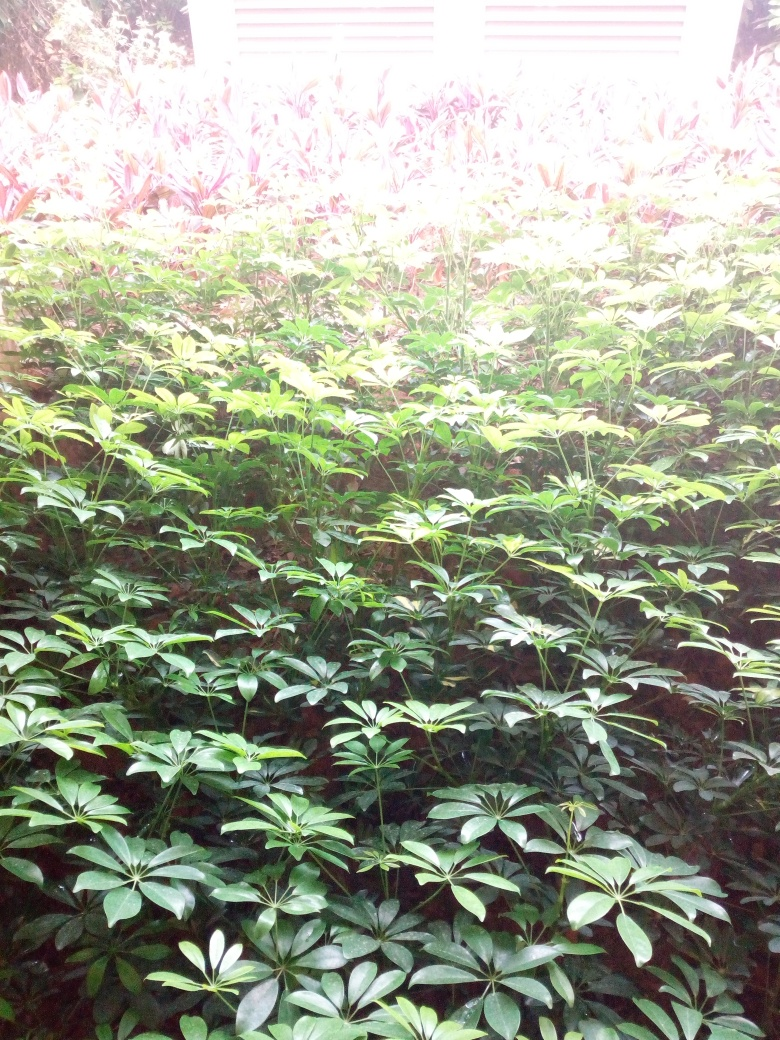Is this environment natural or cultivated? The arrangement of plants and the uniformity of the species suggest that this is a cultivated environment, perhaps part of a landscaped garden or park. The plants seem to be well-maintained and intentionally placed, which would be less likely in a completely natural setting. 